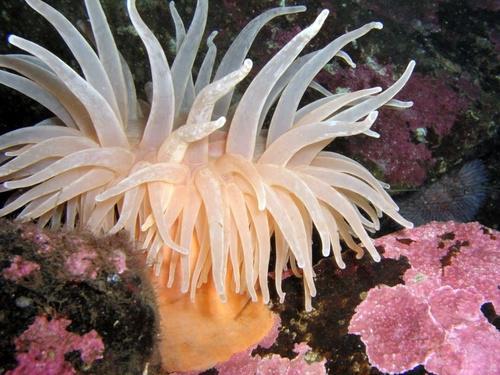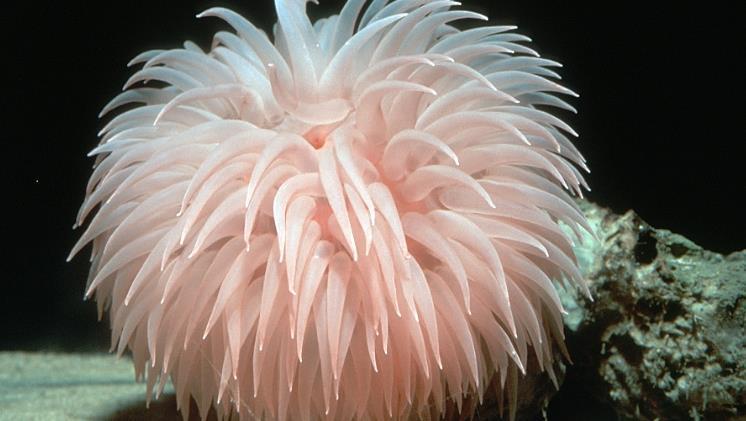The first image is the image on the left, the second image is the image on the right. Assess this claim about the two images: "Right image shows two flower-shaped anemones.". Correct or not? Answer yes or no. No. The first image is the image on the left, the second image is the image on the right. For the images displayed, is the sentence "There are two anemones in the image on the right." factually correct? Answer yes or no. No. 